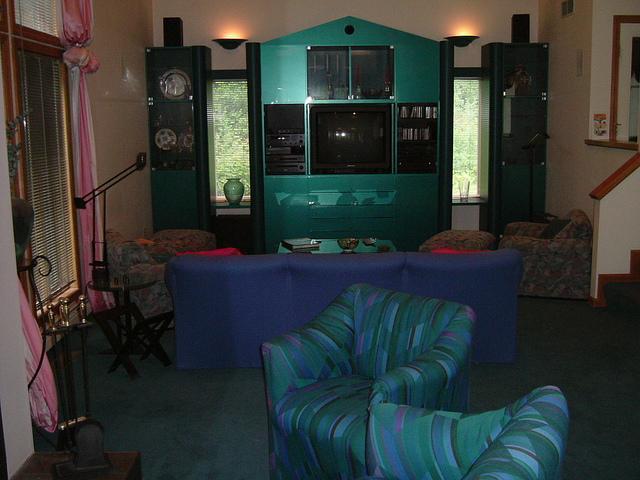How many chairs are there?
Give a very brief answer. 4. How many couches are in the photo?
Give a very brief answer. 2. 